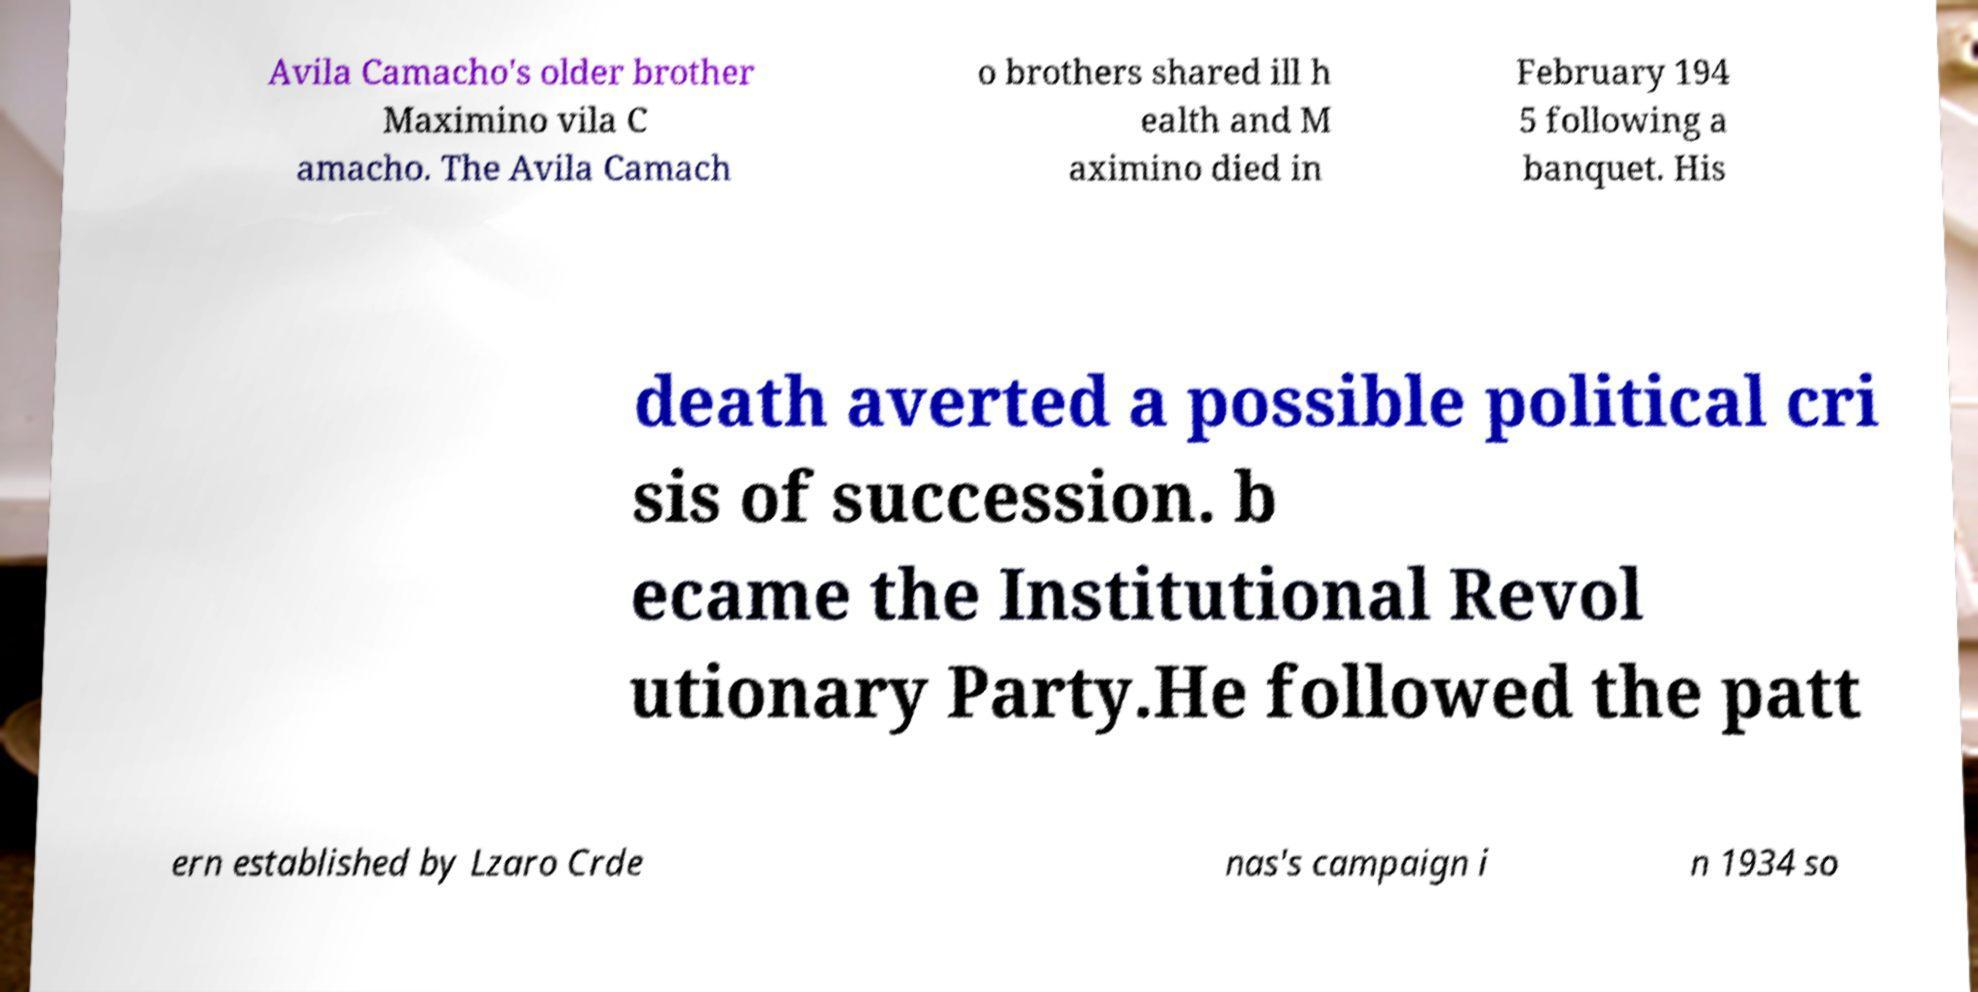For documentation purposes, I need the text within this image transcribed. Could you provide that? Avila Camacho's older brother Maximino vila C amacho. The Avila Camach o brothers shared ill h ealth and M aximino died in February 194 5 following a banquet. His death averted a possible political cri sis of succession. b ecame the Institutional Revol utionary Party.He followed the patt ern established by Lzaro Crde nas's campaign i n 1934 so 